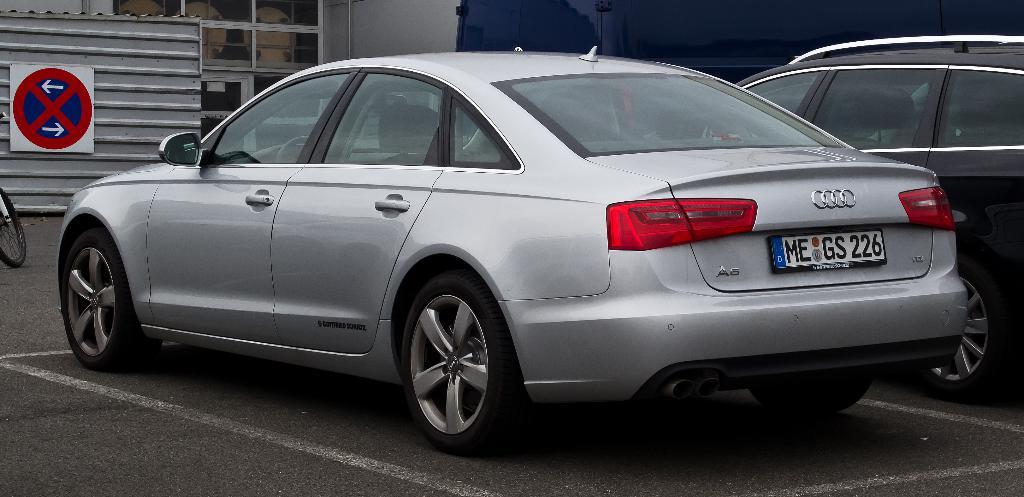What is the lat number on the tag?
Offer a terse response. 6. 